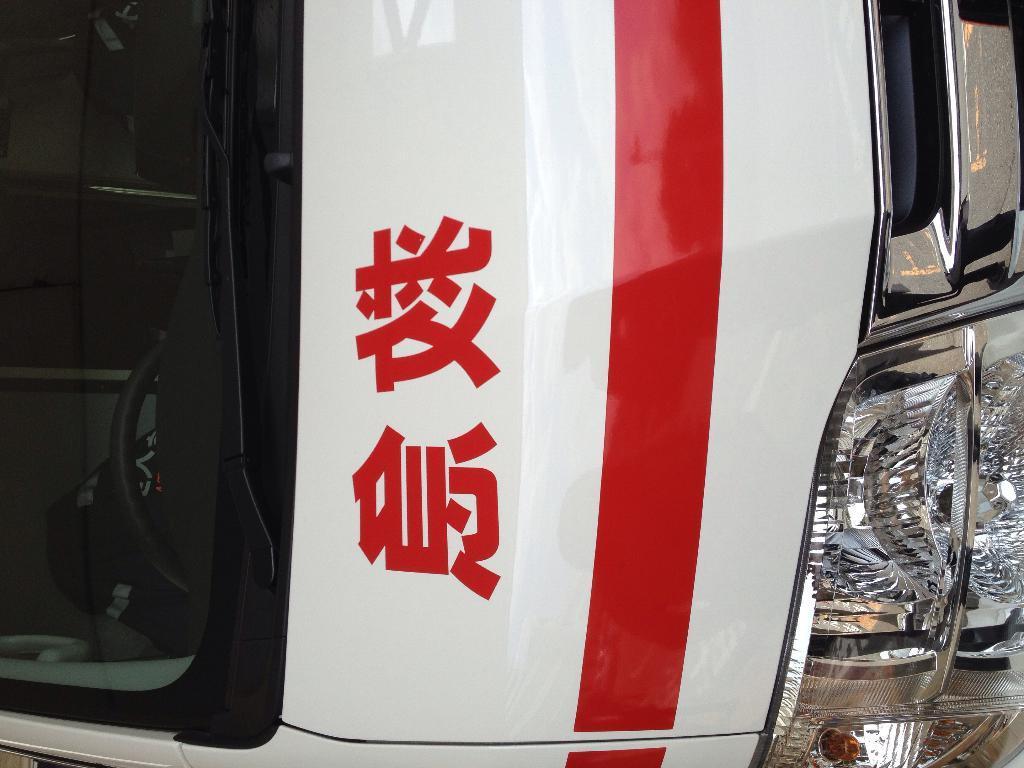Describe this image in one or two sentences. In this image we can see front view of the bus. 